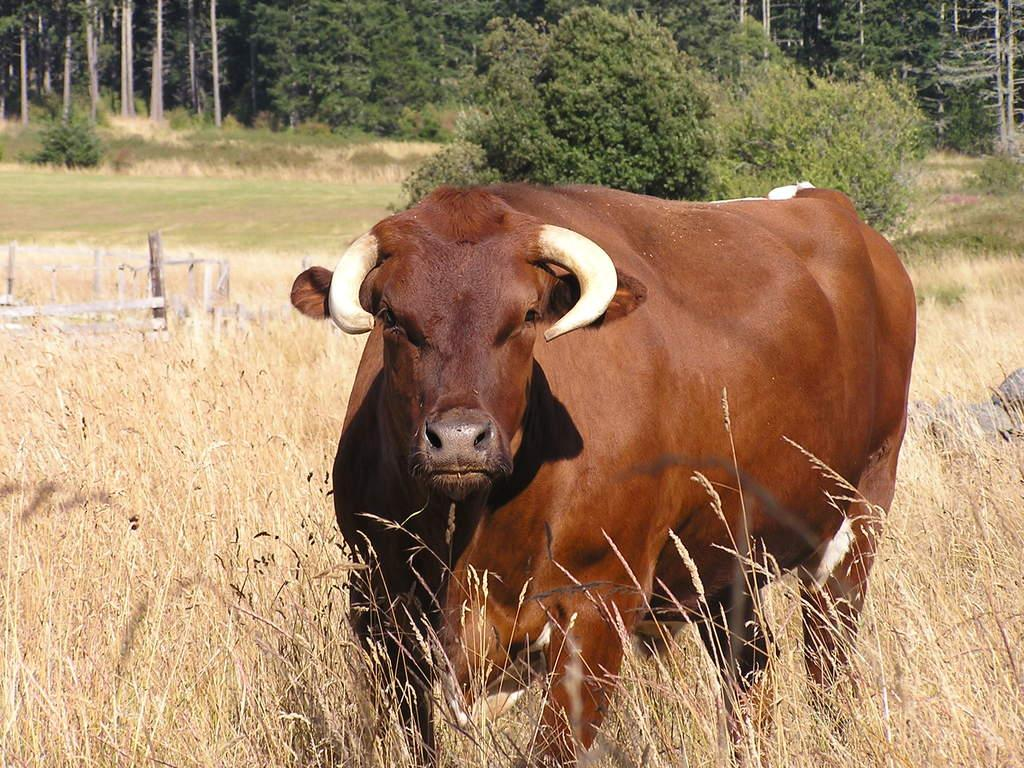What animal can be seen in the image? There is a cow in the image. What other living organisms are present in the image? There are plants in the image. What can be seen in the background of the image? In the background, there are stones, wooden objects, plants, and trees. What type of goldfish can be seen swimming in the image? There are no goldfish present in the image; it features a cow and various background elements. What religious symbols or practices can be observed in the image? There are no religious symbols or practices depicted in the image. 